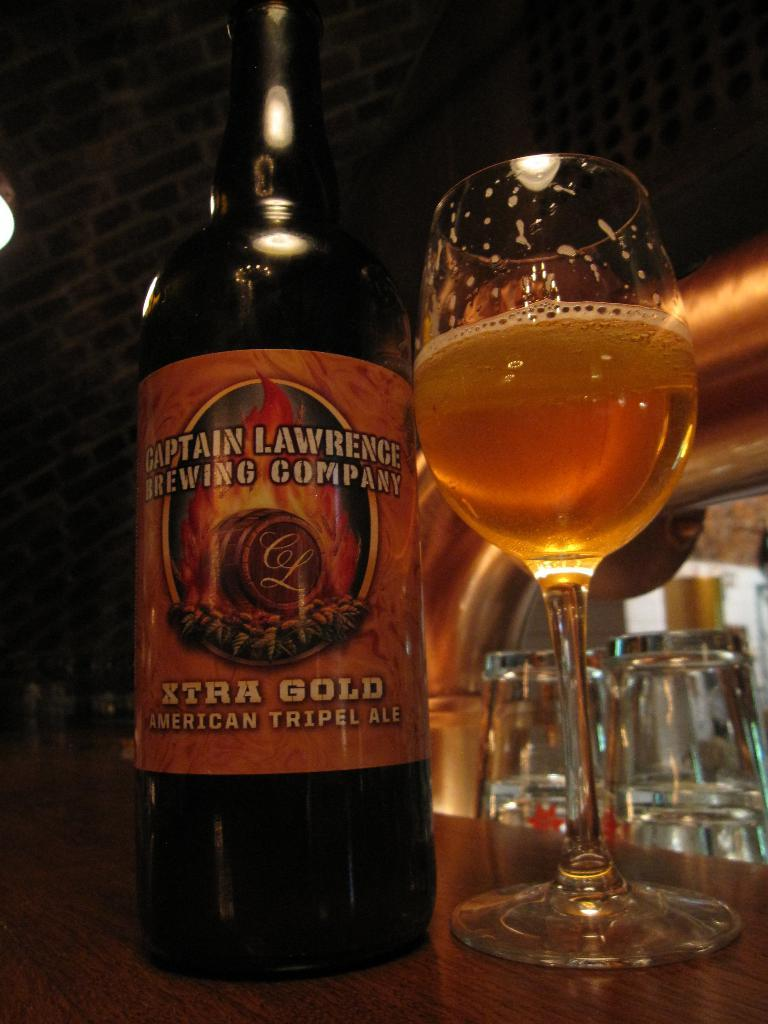What is placed on the table in the image? There is a bottle and a glass of drink placed on a table in the image. What is inside the glass of drink? The contents of the glass of drink are not visible in the image. What can be seen in the background of the image? There are glasses and a wall in the background of the image. How many boys are copying the mark on the wall in the image? There are no boys or marks on the wall in the image. 